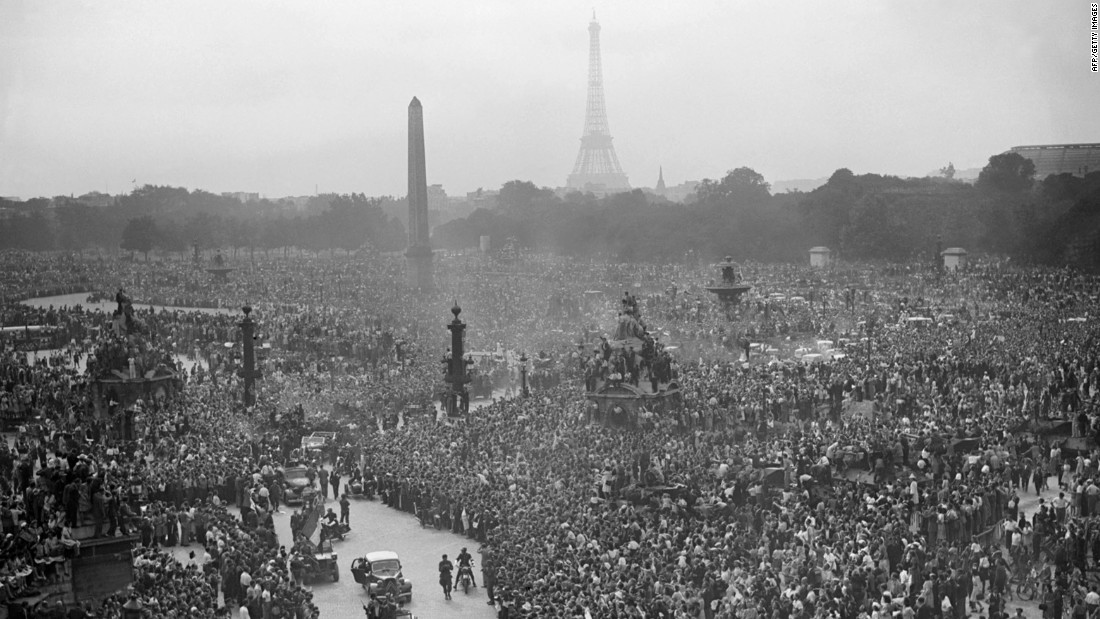Given the historical context suggested by the image, which significant event in French history could this photograph potentially represent, and why would it attract such a vast number of people to this particular location? The photograph likely depicts a pivotal moment in French history, possibly the celebration of the Liberation of Paris at the end of World War II. Place de la Concorde, as shown in the image, has been a site of numerous momentous events throughout French history, including gatherings during the French Revolution. The immense crowd, along with the use of vehicles and the styles of dresses, strongly suggests a post-war celebration. People climbing statues and lampposts indicate the emotional and significant nature of the event, revealing a euphoric and participatory atmosphere. Such a dense and eager crowd is typical of monumental events marking national pride and relief, likely associated with a historical turning point such as the end of occupation and a return to freedom. 